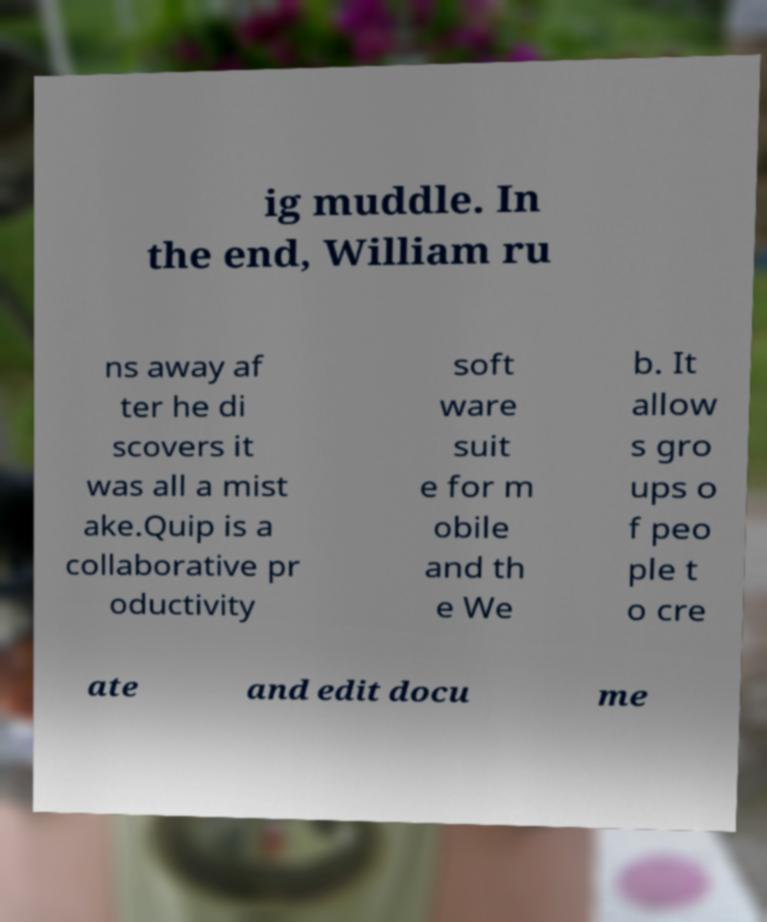Please read and relay the text visible in this image. What does it say? ig muddle. In the end, William ru ns away af ter he di scovers it was all a mist ake.Quip is a collaborative pr oductivity soft ware suit e for m obile and th e We b. It allow s gro ups o f peo ple t o cre ate and edit docu me 